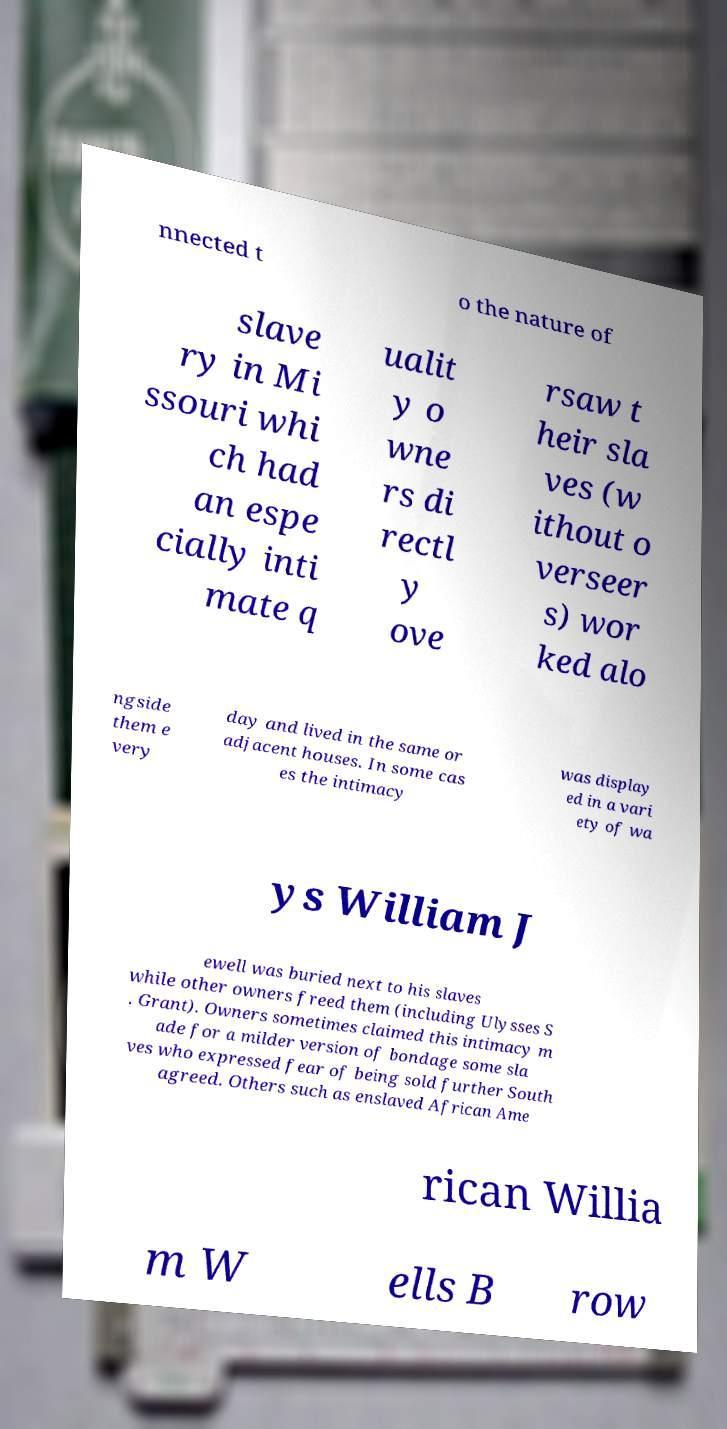There's text embedded in this image that I need extracted. Can you transcribe it verbatim? nnected t o the nature of slave ry in Mi ssouri whi ch had an espe cially inti mate q ualit y o wne rs di rectl y ove rsaw t heir sla ves (w ithout o verseer s) wor ked alo ngside them e very day and lived in the same or adjacent houses. In some cas es the intimacy was display ed in a vari ety of wa ys William J ewell was buried next to his slaves while other owners freed them (including Ulysses S . Grant). Owners sometimes claimed this intimacy m ade for a milder version of bondage some sla ves who expressed fear of being sold further South agreed. Others such as enslaved African Ame rican Willia m W ells B row 